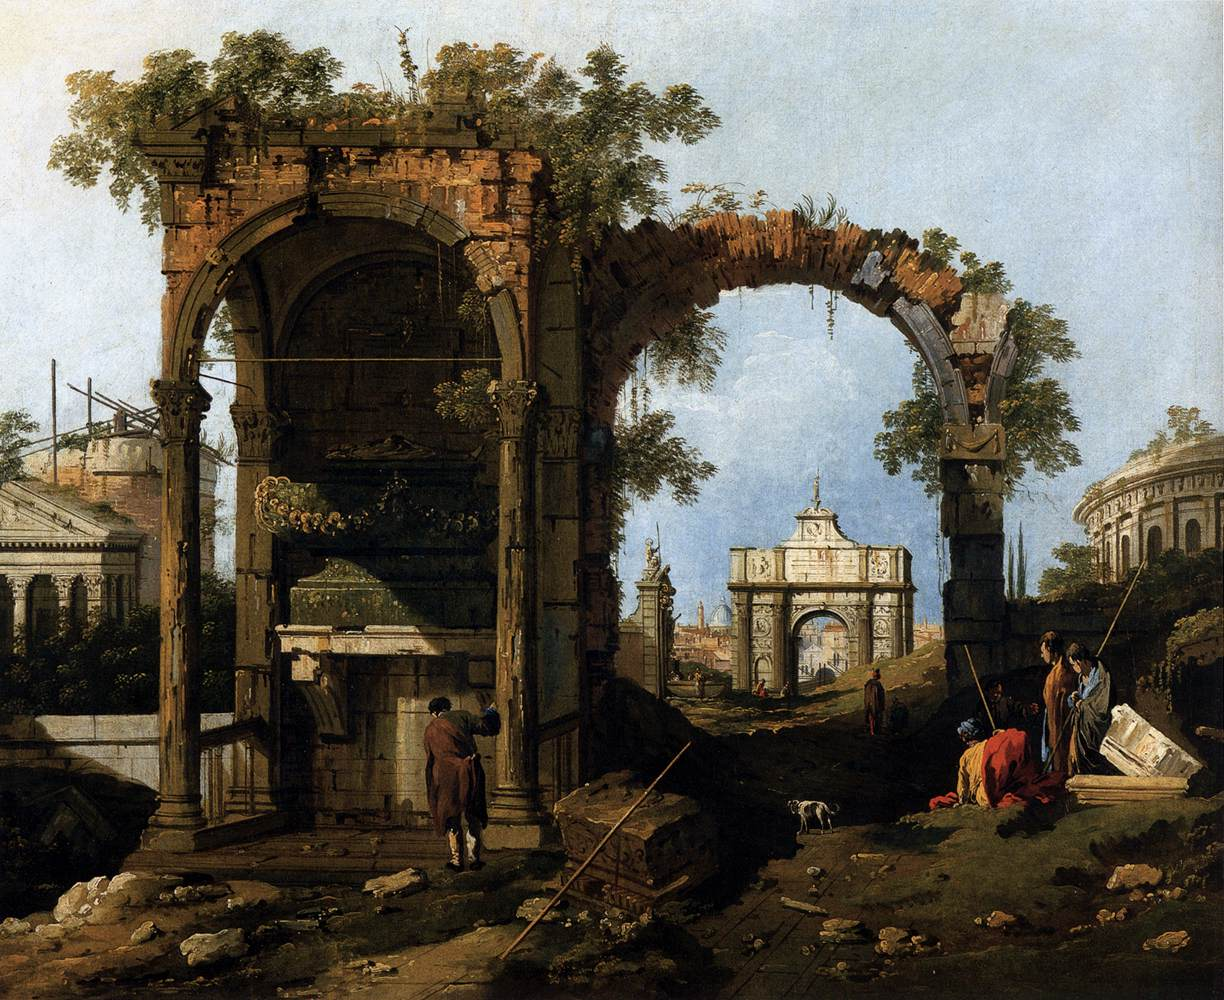Pretend you are an archaeologist discovering this site. What significant findings would you report? As an archaeologist, I would report that the site provides invaluable insights into the architectural prowess and cultural life of the ancient civilization that once flourished here. The grand archway with its intricate carvings suggests it was a significant monument, possibly commemorating a major historical event or figure. The smaller archway, also artistically adorned, indicates the presence of complex structures that further hint at advanced engineering skills. The lush foliage growing amidst the ruins implies a long period of abandonment, during which nature reclaimed parts of the man-made landscape. The scattered remnants of pottery and tools around the figures suggest daily life activities, offering a window into the socio-economic fabric of the time. Furthermore, any inscriptions or artifacts discovered would provide crucial context, potentially expanding our understanding of this era's language, beliefs, and practices. Describe your initial feelings upon uncovering such a historic site. The moment of uncovering such a historic site would be one of awe and reverence. The realization that I am standing amidst the vestiges of an ancient civilization would fill me with a profound sense of connection to the past. The beauty of the ruins, juxtaposed with their state of decay, would evoke mixed feelings of admiration for their creators and sadness for their decline. The discovery would also spark an intense curiosity and excitement to uncover the stories, knowledge, and secrets the site holds. The sense of awe would be coupled with a strong responsibility to meticulously study and preserve the findings for future generations. 